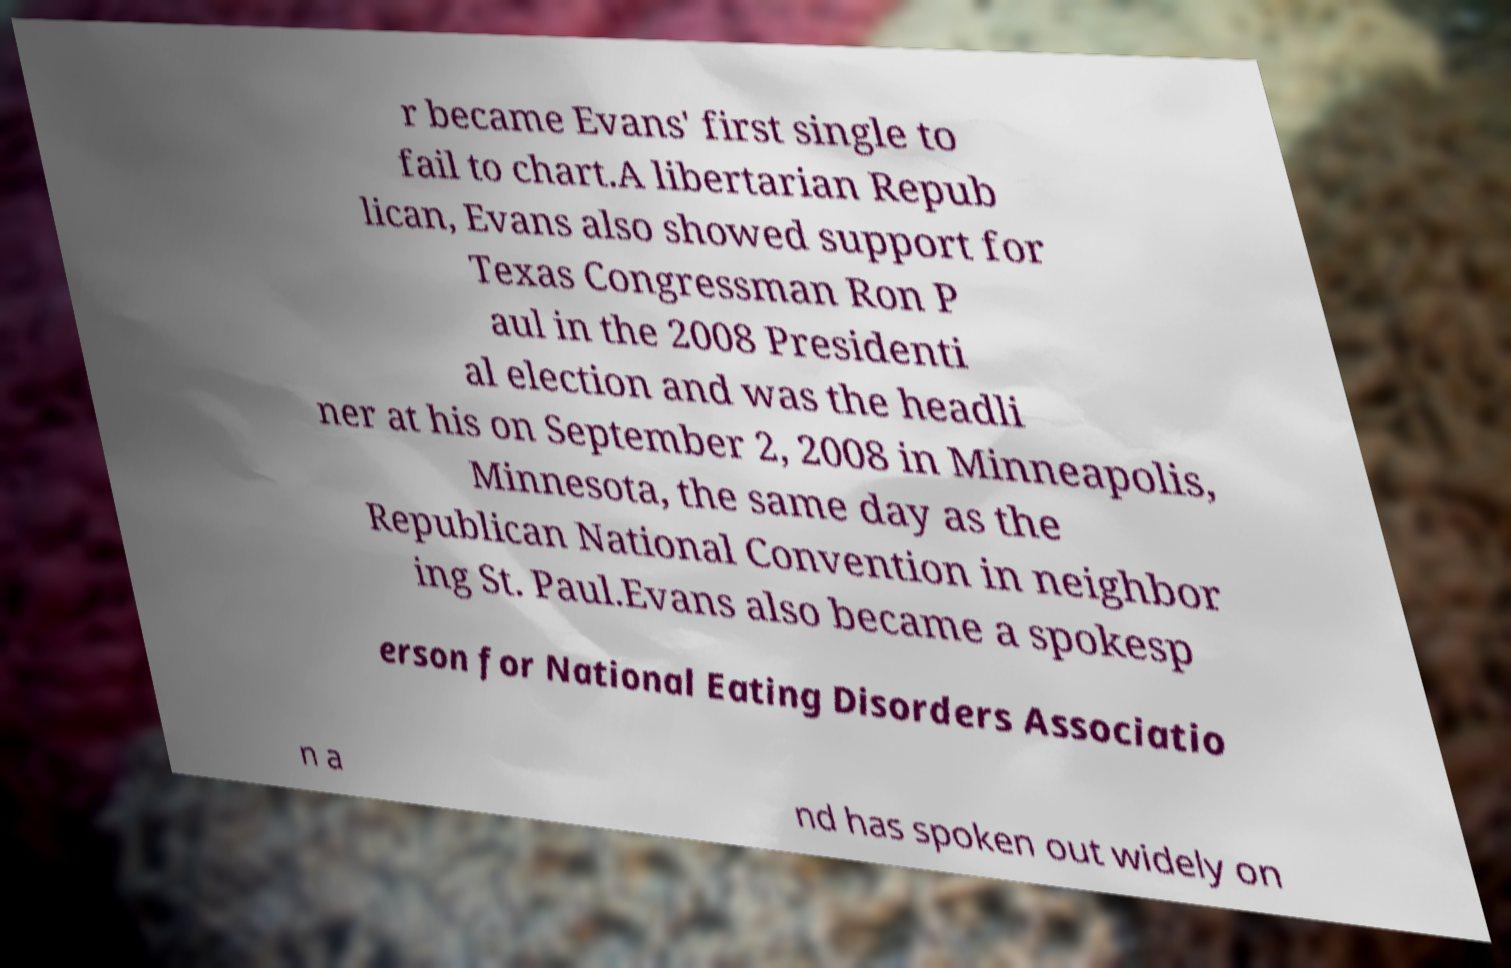Could you extract and type out the text from this image? r became Evans' first single to fail to chart.A libertarian Repub lican, Evans also showed support for Texas Congressman Ron P aul in the 2008 Presidenti al election and was the headli ner at his on September 2, 2008 in Minneapolis, Minnesota, the same day as the Republican National Convention in neighbor ing St. Paul.Evans also became a spokesp erson for National Eating Disorders Associatio n a nd has spoken out widely on 